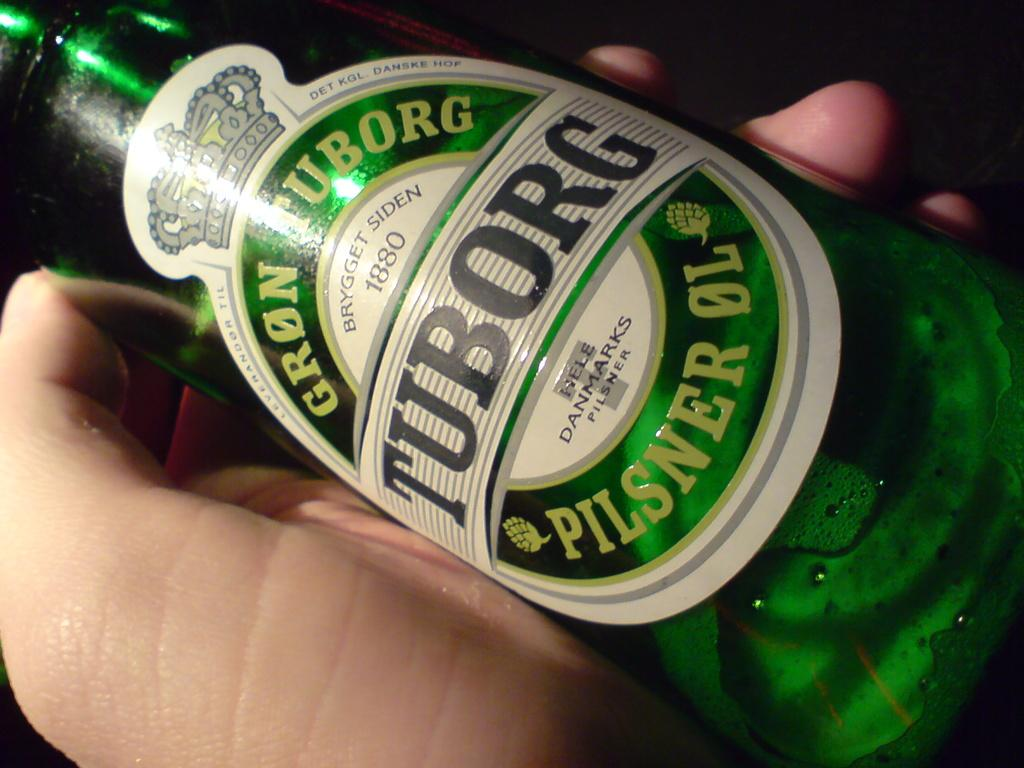What is the main object in the center of the image? There is a bottle in the center of the image. Can you describe anything else in the image? There is a person's hand beside the bottle. What type of beef is being prepared in the image? There is no beef present in the image; it only features a bottle and a person's hand. How many clams are visible in the image? There are no clams present in the image. 